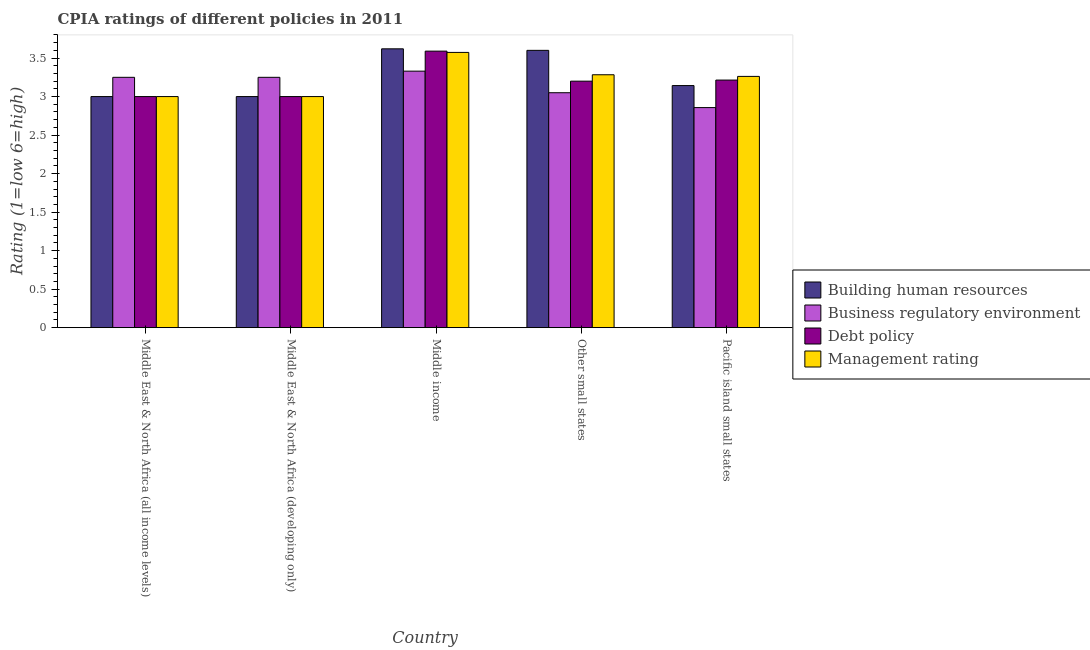How many different coloured bars are there?
Your response must be concise. 4. How many groups of bars are there?
Offer a terse response. 5. Are the number of bars per tick equal to the number of legend labels?
Offer a terse response. Yes. How many bars are there on the 2nd tick from the left?
Offer a terse response. 4. How many bars are there on the 1st tick from the right?
Ensure brevity in your answer.  4. What is the label of the 1st group of bars from the left?
Offer a very short reply. Middle East & North Africa (all income levels). In how many cases, is the number of bars for a given country not equal to the number of legend labels?
Provide a short and direct response. 0. Across all countries, what is the maximum cpia rating of business regulatory environment?
Offer a very short reply. 3.33. Across all countries, what is the minimum cpia rating of management?
Offer a very short reply. 3. In which country was the cpia rating of building human resources minimum?
Your answer should be very brief. Middle East & North Africa (all income levels). What is the total cpia rating of business regulatory environment in the graph?
Make the answer very short. 15.74. What is the difference between the cpia rating of debt policy in Other small states and that in Pacific island small states?
Your response must be concise. -0.01. What is the difference between the cpia rating of management in Pacific island small states and the cpia rating of business regulatory environment in Middle East & North Africa (developing only)?
Your answer should be very brief. 0.01. What is the average cpia rating of building human resources per country?
Keep it short and to the point. 3.27. What is the ratio of the cpia rating of management in Middle East & North Africa (all income levels) to that in Other small states?
Offer a very short reply. 0.91. Is the cpia rating of debt policy in Other small states less than that in Pacific island small states?
Keep it short and to the point. Yes. What is the difference between the highest and the second highest cpia rating of building human resources?
Your response must be concise. 0.02. What is the difference between the highest and the lowest cpia rating of building human resources?
Keep it short and to the point. 0.62. Is it the case that in every country, the sum of the cpia rating of business regulatory environment and cpia rating of debt policy is greater than the sum of cpia rating of management and cpia rating of building human resources?
Provide a succinct answer. Yes. What does the 2nd bar from the left in Middle East & North Africa (developing only) represents?
Provide a short and direct response. Business regulatory environment. What does the 4th bar from the right in Middle East & North Africa (all income levels) represents?
Ensure brevity in your answer.  Building human resources. Is it the case that in every country, the sum of the cpia rating of building human resources and cpia rating of business regulatory environment is greater than the cpia rating of debt policy?
Offer a very short reply. Yes. How many bars are there?
Your answer should be compact. 20. Are all the bars in the graph horizontal?
Offer a terse response. No. Are the values on the major ticks of Y-axis written in scientific E-notation?
Your answer should be compact. No. Does the graph contain grids?
Provide a succinct answer. No. Where does the legend appear in the graph?
Make the answer very short. Center right. What is the title of the graph?
Your response must be concise. CPIA ratings of different policies in 2011. Does "Norway" appear as one of the legend labels in the graph?
Offer a very short reply. No. What is the label or title of the X-axis?
Offer a very short reply. Country. What is the Rating (1=low 6=high) in Debt policy in Middle East & North Africa (all income levels)?
Make the answer very short. 3. What is the Rating (1=low 6=high) in Business regulatory environment in Middle East & North Africa (developing only)?
Your response must be concise. 3.25. What is the Rating (1=low 6=high) of Debt policy in Middle East & North Africa (developing only)?
Offer a very short reply. 3. What is the Rating (1=low 6=high) in Building human resources in Middle income?
Keep it short and to the point. 3.62. What is the Rating (1=low 6=high) of Business regulatory environment in Middle income?
Your answer should be very brief. 3.33. What is the Rating (1=low 6=high) of Debt policy in Middle income?
Your response must be concise. 3.59. What is the Rating (1=low 6=high) of Management rating in Middle income?
Make the answer very short. 3.57. What is the Rating (1=low 6=high) in Building human resources in Other small states?
Your answer should be compact. 3.6. What is the Rating (1=low 6=high) in Business regulatory environment in Other small states?
Offer a very short reply. 3.05. What is the Rating (1=low 6=high) of Management rating in Other small states?
Keep it short and to the point. 3.28. What is the Rating (1=low 6=high) in Building human resources in Pacific island small states?
Provide a succinct answer. 3.14. What is the Rating (1=low 6=high) of Business regulatory environment in Pacific island small states?
Provide a succinct answer. 2.86. What is the Rating (1=low 6=high) of Debt policy in Pacific island small states?
Offer a very short reply. 3.21. What is the Rating (1=low 6=high) of Management rating in Pacific island small states?
Offer a terse response. 3.26. Across all countries, what is the maximum Rating (1=low 6=high) of Building human resources?
Keep it short and to the point. 3.62. Across all countries, what is the maximum Rating (1=low 6=high) of Business regulatory environment?
Your answer should be very brief. 3.33. Across all countries, what is the maximum Rating (1=low 6=high) in Debt policy?
Ensure brevity in your answer.  3.59. Across all countries, what is the maximum Rating (1=low 6=high) of Management rating?
Make the answer very short. 3.57. Across all countries, what is the minimum Rating (1=low 6=high) of Building human resources?
Keep it short and to the point. 3. Across all countries, what is the minimum Rating (1=low 6=high) of Business regulatory environment?
Keep it short and to the point. 2.86. Across all countries, what is the minimum Rating (1=low 6=high) in Management rating?
Provide a succinct answer. 3. What is the total Rating (1=low 6=high) in Building human resources in the graph?
Offer a very short reply. 16.36. What is the total Rating (1=low 6=high) in Business regulatory environment in the graph?
Provide a succinct answer. 15.74. What is the total Rating (1=low 6=high) in Debt policy in the graph?
Give a very brief answer. 16. What is the total Rating (1=low 6=high) of Management rating in the graph?
Provide a short and direct response. 16.12. What is the difference between the Rating (1=low 6=high) in Building human resources in Middle East & North Africa (all income levels) and that in Middle income?
Offer a terse response. -0.62. What is the difference between the Rating (1=low 6=high) of Business regulatory environment in Middle East & North Africa (all income levels) and that in Middle income?
Give a very brief answer. -0.08. What is the difference between the Rating (1=low 6=high) in Debt policy in Middle East & North Africa (all income levels) and that in Middle income?
Your answer should be compact. -0.59. What is the difference between the Rating (1=low 6=high) of Management rating in Middle East & North Africa (all income levels) and that in Middle income?
Make the answer very short. -0.57. What is the difference between the Rating (1=low 6=high) of Business regulatory environment in Middle East & North Africa (all income levels) and that in Other small states?
Your response must be concise. 0.2. What is the difference between the Rating (1=low 6=high) in Debt policy in Middle East & North Africa (all income levels) and that in Other small states?
Offer a terse response. -0.2. What is the difference between the Rating (1=low 6=high) of Management rating in Middle East & North Africa (all income levels) and that in Other small states?
Ensure brevity in your answer.  -0.28. What is the difference between the Rating (1=low 6=high) of Building human resources in Middle East & North Africa (all income levels) and that in Pacific island small states?
Provide a succinct answer. -0.14. What is the difference between the Rating (1=low 6=high) of Business regulatory environment in Middle East & North Africa (all income levels) and that in Pacific island small states?
Give a very brief answer. 0.39. What is the difference between the Rating (1=low 6=high) of Debt policy in Middle East & North Africa (all income levels) and that in Pacific island small states?
Offer a terse response. -0.21. What is the difference between the Rating (1=low 6=high) in Management rating in Middle East & North Africa (all income levels) and that in Pacific island small states?
Ensure brevity in your answer.  -0.26. What is the difference between the Rating (1=low 6=high) in Building human resources in Middle East & North Africa (developing only) and that in Middle income?
Keep it short and to the point. -0.62. What is the difference between the Rating (1=low 6=high) of Business regulatory environment in Middle East & North Africa (developing only) and that in Middle income?
Keep it short and to the point. -0.08. What is the difference between the Rating (1=low 6=high) of Debt policy in Middle East & North Africa (developing only) and that in Middle income?
Provide a short and direct response. -0.59. What is the difference between the Rating (1=low 6=high) in Management rating in Middle East & North Africa (developing only) and that in Middle income?
Offer a terse response. -0.57. What is the difference between the Rating (1=low 6=high) in Building human resources in Middle East & North Africa (developing only) and that in Other small states?
Offer a very short reply. -0.6. What is the difference between the Rating (1=low 6=high) of Debt policy in Middle East & North Africa (developing only) and that in Other small states?
Offer a terse response. -0.2. What is the difference between the Rating (1=low 6=high) of Management rating in Middle East & North Africa (developing only) and that in Other small states?
Keep it short and to the point. -0.28. What is the difference between the Rating (1=low 6=high) in Building human resources in Middle East & North Africa (developing only) and that in Pacific island small states?
Make the answer very short. -0.14. What is the difference between the Rating (1=low 6=high) in Business regulatory environment in Middle East & North Africa (developing only) and that in Pacific island small states?
Keep it short and to the point. 0.39. What is the difference between the Rating (1=low 6=high) of Debt policy in Middle East & North Africa (developing only) and that in Pacific island small states?
Make the answer very short. -0.21. What is the difference between the Rating (1=low 6=high) of Management rating in Middle East & North Africa (developing only) and that in Pacific island small states?
Your response must be concise. -0.26. What is the difference between the Rating (1=low 6=high) in Business regulatory environment in Middle income and that in Other small states?
Offer a terse response. 0.28. What is the difference between the Rating (1=low 6=high) in Debt policy in Middle income and that in Other small states?
Give a very brief answer. 0.39. What is the difference between the Rating (1=low 6=high) of Management rating in Middle income and that in Other small states?
Keep it short and to the point. 0.29. What is the difference between the Rating (1=low 6=high) of Building human resources in Middle income and that in Pacific island small states?
Offer a terse response. 0.48. What is the difference between the Rating (1=low 6=high) of Business regulatory environment in Middle income and that in Pacific island small states?
Offer a very short reply. 0.47. What is the difference between the Rating (1=low 6=high) in Debt policy in Middle income and that in Pacific island small states?
Offer a very short reply. 0.38. What is the difference between the Rating (1=low 6=high) in Management rating in Middle income and that in Pacific island small states?
Your response must be concise. 0.31. What is the difference between the Rating (1=low 6=high) of Building human resources in Other small states and that in Pacific island small states?
Ensure brevity in your answer.  0.46. What is the difference between the Rating (1=low 6=high) in Business regulatory environment in Other small states and that in Pacific island small states?
Your answer should be very brief. 0.19. What is the difference between the Rating (1=low 6=high) in Debt policy in Other small states and that in Pacific island small states?
Ensure brevity in your answer.  -0.01. What is the difference between the Rating (1=low 6=high) in Management rating in Other small states and that in Pacific island small states?
Ensure brevity in your answer.  0.02. What is the difference between the Rating (1=low 6=high) in Building human resources in Middle East & North Africa (all income levels) and the Rating (1=low 6=high) in Business regulatory environment in Middle East & North Africa (developing only)?
Provide a short and direct response. -0.25. What is the difference between the Rating (1=low 6=high) of Business regulatory environment in Middle East & North Africa (all income levels) and the Rating (1=low 6=high) of Management rating in Middle East & North Africa (developing only)?
Your answer should be compact. 0.25. What is the difference between the Rating (1=low 6=high) of Building human resources in Middle East & North Africa (all income levels) and the Rating (1=low 6=high) of Business regulatory environment in Middle income?
Your answer should be very brief. -0.33. What is the difference between the Rating (1=low 6=high) of Building human resources in Middle East & North Africa (all income levels) and the Rating (1=low 6=high) of Debt policy in Middle income?
Offer a very short reply. -0.59. What is the difference between the Rating (1=low 6=high) in Building human resources in Middle East & North Africa (all income levels) and the Rating (1=low 6=high) in Management rating in Middle income?
Offer a very short reply. -0.57. What is the difference between the Rating (1=low 6=high) of Business regulatory environment in Middle East & North Africa (all income levels) and the Rating (1=low 6=high) of Debt policy in Middle income?
Make the answer very short. -0.34. What is the difference between the Rating (1=low 6=high) in Business regulatory environment in Middle East & North Africa (all income levels) and the Rating (1=low 6=high) in Management rating in Middle income?
Provide a succinct answer. -0.32. What is the difference between the Rating (1=low 6=high) of Debt policy in Middle East & North Africa (all income levels) and the Rating (1=low 6=high) of Management rating in Middle income?
Give a very brief answer. -0.57. What is the difference between the Rating (1=low 6=high) in Building human resources in Middle East & North Africa (all income levels) and the Rating (1=low 6=high) in Debt policy in Other small states?
Ensure brevity in your answer.  -0.2. What is the difference between the Rating (1=low 6=high) in Building human resources in Middle East & North Africa (all income levels) and the Rating (1=low 6=high) in Management rating in Other small states?
Your response must be concise. -0.28. What is the difference between the Rating (1=low 6=high) of Business regulatory environment in Middle East & North Africa (all income levels) and the Rating (1=low 6=high) of Debt policy in Other small states?
Your response must be concise. 0.05. What is the difference between the Rating (1=low 6=high) in Business regulatory environment in Middle East & North Africa (all income levels) and the Rating (1=low 6=high) in Management rating in Other small states?
Give a very brief answer. -0.03. What is the difference between the Rating (1=low 6=high) of Debt policy in Middle East & North Africa (all income levels) and the Rating (1=low 6=high) of Management rating in Other small states?
Your answer should be compact. -0.28. What is the difference between the Rating (1=low 6=high) in Building human resources in Middle East & North Africa (all income levels) and the Rating (1=low 6=high) in Business regulatory environment in Pacific island small states?
Your answer should be very brief. 0.14. What is the difference between the Rating (1=low 6=high) in Building human resources in Middle East & North Africa (all income levels) and the Rating (1=low 6=high) in Debt policy in Pacific island small states?
Ensure brevity in your answer.  -0.21. What is the difference between the Rating (1=low 6=high) in Building human resources in Middle East & North Africa (all income levels) and the Rating (1=low 6=high) in Management rating in Pacific island small states?
Your answer should be very brief. -0.26. What is the difference between the Rating (1=low 6=high) in Business regulatory environment in Middle East & North Africa (all income levels) and the Rating (1=low 6=high) in Debt policy in Pacific island small states?
Ensure brevity in your answer.  0.04. What is the difference between the Rating (1=low 6=high) in Business regulatory environment in Middle East & North Africa (all income levels) and the Rating (1=low 6=high) in Management rating in Pacific island small states?
Your response must be concise. -0.01. What is the difference between the Rating (1=low 6=high) in Debt policy in Middle East & North Africa (all income levels) and the Rating (1=low 6=high) in Management rating in Pacific island small states?
Make the answer very short. -0.26. What is the difference between the Rating (1=low 6=high) in Building human resources in Middle East & North Africa (developing only) and the Rating (1=low 6=high) in Business regulatory environment in Middle income?
Provide a short and direct response. -0.33. What is the difference between the Rating (1=low 6=high) in Building human resources in Middle East & North Africa (developing only) and the Rating (1=low 6=high) in Debt policy in Middle income?
Keep it short and to the point. -0.59. What is the difference between the Rating (1=low 6=high) in Building human resources in Middle East & North Africa (developing only) and the Rating (1=low 6=high) in Management rating in Middle income?
Your answer should be compact. -0.57. What is the difference between the Rating (1=low 6=high) of Business regulatory environment in Middle East & North Africa (developing only) and the Rating (1=low 6=high) of Debt policy in Middle income?
Ensure brevity in your answer.  -0.34. What is the difference between the Rating (1=low 6=high) of Business regulatory environment in Middle East & North Africa (developing only) and the Rating (1=low 6=high) of Management rating in Middle income?
Ensure brevity in your answer.  -0.32. What is the difference between the Rating (1=low 6=high) of Debt policy in Middle East & North Africa (developing only) and the Rating (1=low 6=high) of Management rating in Middle income?
Ensure brevity in your answer.  -0.57. What is the difference between the Rating (1=low 6=high) of Building human resources in Middle East & North Africa (developing only) and the Rating (1=low 6=high) of Debt policy in Other small states?
Your answer should be compact. -0.2. What is the difference between the Rating (1=low 6=high) in Building human resources in Middle East & North Africa (developing only) and the Rating (1=low 6=high) in Management rating in Other small states?
Give a very brief answer. -0.28. What is the difference between the Rating (1=low 6=high) of Business regulatory environment in Middle East & North Africa (developing only) and the Rating (1=low 6=high) of Debt policy in Other small states?
Ensure brevity in your answer.  0.05. What is the difference between the Rating (1=low 6=high) in Business regulatory environment in Middle East & North Africa (developing only) and the Rating (1=low 6=high) in Management rating in Other small states?
Give a very brief answer. -0.03. What is the difference between the Rating (1=low 6=high) of Debt policy in Middle East & North Africa (developing only) and the Rating (1=low 6=high) of Management rating in Other small states?
Offer a terse response. -0.28. What is the difference between the Rating (1=low 6=high) in Building human resources in Middle East & North Africa (developing only) and the Rating (1=low 6=high) in Business regulatory environment in Pacific island small states?
Give a very brief answer. 0.14. What is the difference between the Rating (1=low 6=high) in Building human resources in Middle East & North Africa (developing only) and the Rating (1=low 6=high) in Debt policy in Pacific island small states?
Your response must be concise. -0.21. What is the difference between the Rating (1=low 6=high) in Building human resources in Middle East & North Africa (developing only) and the Rating (1=low 6=high) in Management rating in Pacific island small states?
Offer a terse response. -0.26. What is the difference between the Rating (1=low 6=high) in Business regulatory environment in Middle East & North Africa (developing only) and the Rating (1=low 6=high) in Debt policy in Pacific island small states?
Keep it short and to the point. 0.04. What is the difference between the Rating (1=low 6=high) of Business regulatory environment in Middle East & North Africa (developing only) and the Rating (1=low 6=high) of Management rating in Pacific island small states?
Provide a succinct answer. -0.01. What is the difference between the Rating (1=low 6=high) in Debt policy in Middle East & North Africa (developing only) and the Rating (1=low 6=high) in Management rating in Pacific island small states?
Offer a terse response. -0.26. What is the difference between the Rating (1=low 6=high) of Building human resources in Middle income and the Rating (1=low 6=high) of Business regulatory environment in Other small states?
Offer a terse response. 0.57. What is the difference between the Rating (1=low 6=high) of Building human resources in Middle income and the Rating (1=low 6=high) of Debt policy in Other small states?
Keep it short and to the point. 0.42. What is the difference between the Rating (1=low 6=high) in Building human resources in Middle income and the Rating (1=low 6=high) in Management rating in Other small states?
Keep it short and to the point. 0.34. What is the difference between the Rating (1=low 6=high) in Business regulatory environment in Middle income and the Rating (1=low 6=high) in Debt policy in Other small states?
Offer a very short reply. 0.13. What is the difference between the Rating (1=low 6=high) of Business regulatory environment in Middle income and the Rating (1=low 6=high) of Management rating in Other small states?
Your answer should be very brief. 0.05. What is the difference between the Rating (1=low 6=high) of Debt policy in Middle income and the Rating (1=low 6=high) of Management rating in Other small states?
Give a very brief answer. 0.31. What is the difference between the Rating (1=low 6=high) in Building human resources in Middle income and the Rating (1=low 6=high) in Business regulatory environment in Pacific island small states?
Offer a very short reply. 0.76. What is the difference between the Rating (1=low 6=high) in Building human resources in Middle income and the Rating (1=low 6=high) in Debt policy in Pacific island small states?
Give a very brief answer. 0.41. What is the difference between the Rating (1=low 6=high) of Building human resources in Middle income and the Rating (1=low 6=high) of Management rating in Pacific island small states?
Offer a terse response. 0.36. What is the difference between the Rating (1=low 6=high) in Business regulatory environment in Middle income and the Rating (1=low 6=high) in Debt policy in Pacific island small states?
Offer a terse response. 0.12. What is the difference between the Rating (1=low 6=high) in Business regulatory environment in Middle income and the Rating (1=low 6=high) in Management rating in Pacific island small states?
Keep it short and to the point. 0.07. What is the difference between the Rating (1=low 6=high) of Debt policy in Middle income and the Rating (1=low 6=high) of Management rating in Pacific island small states?
Give a very brief answer. 0.33. What is the difference between the Rating (1=low 6=high) of Building human resources in Other small states and the Rating (1=low 6=high) of Business regulatory environment in Pacific island small states?
Offer a terse response. 0.74. What is the difference between the Rating (1=low 6=high) in Building human resources in Other small states and the Rating (1=low 6=high) in Debt policy in Pacific island small states?
Keep it short and to the point. 0.39. What is the difference between the Rating (1=low 6=high) in Building human resources in Other small states and the Rating (1=low 6=high) in Management rating in Pacific island small states?
Offer a terse response. 0.34. What is the difference between the Rating (1=low 6=high) in Business regulatory environment in Other small states and the Rating (1=low 6=high) in Debt policy in Pacific island small states?
Provide a short and direct response. -0.16. What is the difference between the Rating (1=low 6=high) in Business regulatory environment in Other small states and the Rating (1=low 6=high) in Management rating in Pacific island small states?
Offer a very short reply. -0.21. What is the difference between the Rating (1=low 6=high) of Debt policy in Other small states and the Rating (1=low 6=high) of Management rating in Pacific island small states?
Provide a succinct answer. -0.06. What is the average Rating (1=low 6=high) of Building human resources per country?
Provide a short and direct response. 3.27. What is the average Rating (1=low 6=high) of Business regulatory environment per country?
Give a very brief answer. 3.15. What is the average Rating (1=low 6=high) in Debt policy per country?
Your response must be concise. 3.2. What is the average Rating (1=low 6=high) in Management rating per country?
Ensure brevity in your answer.  3.22. What is the difference between the Rating (1=low 6=high) in Building human resources and Rating (1=low 6=high) in Business regulatory environment in Middle East & North Africa (all income levels)?
Provide a succinct answer. -0.25. What is the difference between the Rating (1=low 6=high) in Building human resources and Rating (1=low 6=high) in Management rating in Middle East & North Africa (all income levels)?
Offer a very short reply. 0. What is the difference between the Rating (1=low 6=high) in Business regulatory environment and Rating (1=low 6=high) in Management rating in Middle East & North Africa (all income levels)?
Your answer should be compact. 0.25. What is the difference between the Rating (1=low 6=high) in Debt policy and Rating (1=low 6=high) in Management rating in Middle East & North Africa (all income levels)?
Offer a very short reply. 0. What is the difference between the Rating (1=low 6=high) of Building human resources and Rating (1=low 6=high) of Business regulatory environment in Middle East & North Africa (developing only)?
Offer a very short reply. -0.25. What is the difference between the Rating (1=low 6=high) in Business regulatory environment and Rating (1=low 6=high) in Debt policy in Middle East & North Africa (developing only)?
Make the answer very short. 0.25. What is the difference between the Rating (1=low 6=high) of Business regulatory environment and Rating (1=low 6=high) of Management rating in Middle East & North Africa (developing only)?
Make the answer very short. 0.25. What is the difference between the Rating (1=low 6=high) in Debt policy and Rating (1=low 6=high) in Management rating in Middle East & North Africa (developing only)?
Keep it short and to the point. 0. What is the difference between the Rating (1=low 6=high) of Building human resources and Rating (1=low 6=high) of Business regulatory environment in Middle income?
Your response must be concise. 0.29. What is the difference between the Rating (1=low 6=high) of Building human resources and Rating (1=low 6=high) of Debt policy in Middle income?
Provide a succinct answer. 0.03. What is the difference between the Rating (1=low 6=high) in Building human resources and Rating (1=low 6=high) in Management rating in Middle income?
Ensure brevity in your answer.  0.05. What is the difference between the Rating (1=low 6=high) in Business regulatory environment and Rating (1=low 6=high) in Debt policy in Middle income?
Your response must be concise. -0.26. What is the difference between the Rating (1=low 6=high) in Business regulatory environment and Rating (1=low 6=high) in Management rating in Middle income?
Make the answer very short. -0.24. What is the difference between the Rating (1=low 6=high) in Debt policy and Rating (1=low 6=high) in Management rating in Middle income?
Your answer should be compact. 0.02. What is the difference between the Rating (1=low 6=high) of Building human resources and Rating (1=low 6=high) of Business regulatory environment in Other small states?
Provide a succinct answer. 0.55. What is the difference between the Rating (1=low 6=high) in Building human resources and Rating (1=low 6=high) in Debt policy in Other small states?
Keep it short and to the point. 0.4. What is the difference between the Rating (1=low 6=high) of Building human resources and Rating (1=low 6=high) of Management rating in Other small states?
Ensure brevity in your answer.  0.32. What is the difference between the Rating (1=low 6=high) of Business regulatory environment and Rating (1=low 6=high) of Management rating in Other small states?
Offer a very short reply. -0.23. What is the difference between the Rating (1=low 6=high) in Debt policy and Rating (1=low 6=high) in Management rating in Other small states?
Give a very brief answer. -0.08. What is the difference between the Rating (1=low 6=high) in Building human resources and Rating (1=low 6=high) in Business regulatory environment in Pacific island small states?
Your response must be concise. 0.29. What is the difference between the Rating (1=low 6=high) in Building human resources and Rating (1=low 6=high) in Debt policy in Pacific island small states?
Offer a terse response. -0.07. What is the difference between the Rating (1=low 6=high) in Building human resources and Rating (1=low 6=high) in Management rating in Pacific island small states?
Offer a very short reply. -0.12. What is the difference between the Rating (1=low 6=high) in Business regulatory environment and Rating (1=low 6=high) in Debt policy in Pacific island small states?
Your response must be concise. -0.36. What is the difference between the Rating (1=low 6=high) in Business regulatory environment and Rating (1=low 6=high) in Management rating in Pacific island small states?
Provide a succinct answer. -0.4. What is the difference between the Rating (1=low 6=high) in Debt policy and Rating (1=low 6=high) in Management rating in Pacific island small states?
Keep it short and to the point. -0.05. What is the ratio of the Rating (1=low 6=high) of Building human resources in Middle East & North Africa (all income levels) to that in Middle East & North Africa (developing only)?
Provide a short and direct response. 1. What is the ratio of the Rating (1=low 6=high) of Business regulatory environment in Middle East & North Africa (all income levels) to that in Middle East & North Africa (developing only)?
Make the answer very short. 1. What is the ratio of the Rating (1=low 6=high) in Debt policy in Middle East & North Africa (all income levels) to that in Middle East & North Africa (developing only)?
Provide a short and direct response. 1. What is the ratio of the Rating (1=low 6=high) in Building human resources in Middle East & North Africa (all income levels) to that in Middle income?
Your response must be concise. 0.83. What is the ratio of the Rating (1=low 6=high) of Business regulatory environment in Middle East & North Africa (all income levels) to that in Middle income?
Offer a terse response. 0.98. What is the ratio of the Rating (1=low 6=high) in Debt policy in Middle East & North Africa (all income levels) to that in Middle income?
Your answer should be very brief. 0.84. What is the ratio of the Rating (1=low 6=high) of Management rating in Middle East & North Africa (all income levels) to that in Middle income?
Provide a short and direct response. 0.84. What is the ratio of the Rating (1=low 6=high) of Business regulatory environment in Middle East & North Africa (all income levels) to that in Other small states?
Ensure brevity in your answer.  1.07. What is the ratio of the Rating (1=low 6=high) in Debt policy in Middle East & North Africa (all income levels) to that in Other small states?
Provide a short and direct response. 0.94. What is the ratio of the Rating (1=low 6=high) in Management rating in Middle East & North Africa (all income levels) to that in Other small states?
Give a very brief answer. 0.91. What is the ratio of the Rating (1=low 6=high) in Building human resources in Middle East & North Africa (all income levels) to that in Pacific island small states?
Provide a succinct answer. 0.95. What is the ratio of the Rating (1=low 6=high) of Business regulatory environment in Middle East & North Africa (all income levels) to that in Pacific island small states?
Make the answer very short. 1.14. What is the ratio of the Rating (1=low 6=high) in Debt policy in Middle East & North Africa (all income levels) to that in Pacific island small states?
Keep it short and to the point. 0.93. What is the ratio of the Rating (1=low 6=high) in Management rating in Middle East & North Africa (all income levels) to that in Pacific island small states?
Your answer should be very brief. 0.92. What is the ratio of the Rating (1=low 6=high) of Building human resources in Middle East & North Africa (developing only) to that in Middle income?
Provide a short and direct response. 0.83. What is the ratio of the Rating (1=low 6=high) of Debt policy in Middle East & North Africa (developing only) to that in Middle income?
Offer a very short reply. 0.84. What is the ratio of the Rating (1=low 6=high) in Management rating in Middle East & North Africa (developing only) to that in Middle income?
Your answer should be very brief. 0.84. What is the ratio of the Rating (1=low 6=high) of Business regulatory environment in Middle East & North Africa (developing only) to that in Other small states?
Give a very brief answer. 1.07. What is the ratio of the Rating (1=low 6=high) in Management rating in Middle East & North Africa (developing only) to that in Other small states?
Provide a succinct answer. 0.91. What is the ratio of the Rating (1=low 6=high) in Building human resources in Middle East & North Africa (developing only) to that in Pacific island small states?
Offer a terse response. 0.95. What is the ratio of the Rating (1=low 6=high) of Business regulatory environment in Middle East & North Africa (developing only) to that in Pacific island small states?
Your answer should be very brief. 1.14. What is the ratio of the Rating (1=low 6=high) in Management rating in Middle East & North Africa (developing only) to that in Pacific island small states?
Make the answer very short. 0.92. What is the ratio of the Rating (1=low 6=high) of Building human resources in Middle income to that in Other small states?
Ensure brevity in your answer.  1.01. What is the ratio of the Rating (1=low 6=high) in Business regulatory environment in Middle income to that in Other small states?
Your answer should be compact. 1.09. What is the ratio of the Rating (1=low 6=high) in Debt policy in Middle income to that in Other small states?
Ensure brevity in your answer.  1.12. What is the ratio of the Rating (1=low 6=high) of Management rating in Middle income to that in Other small states?
Ensure brevity in your answer.  1.09. What is the ratio of the Rating (1=low 6=high) of Building human resources in Middle income to that in Pacific island small states?
Your answer should be compact. 1.15. What is the ratio of the Rating (1=low 6=high) in Business regulatory environment in Middle income to that in Pacific island small states?
Provide a succinct answer. 1.17. What is the ratio of the Rating (1=low 6=high) of Debt policy in Middle income to that in Pacific island small states?
Provide a short and direct response. 1.12. What is the ratio of the Rating (1=low 6=high) in Management rating in Middle income to that in Pacific island small states?
Provide a succinct answer. 1.1. What is the ratio of the Rating (1=low 6=high) of Building human resources in Other small states to that in Pacific island small states?
Offer a very short reply. 1.15. What is the ratio of the Rating (1=low 6=high) of Business regulatory environment in Other small states to that in Pacific island small states?
Keep it short and to the point. 1.07. What is the ratio of the Rating (1=low 6=high) of Debt policy in Other small states to that in Pacific island small states?
Your answer should be compact. 1. What is the ratio of the Rating (1=low 6=high) of Management rating in Other small states to that in Pacific island small states?
Your answer should be very brief. 1.01. What is the difference between the highest and the second highest Rating (1=low 6=high) of Building human resources?
Your answer should be very brief. 0.02. What is the difference between the highest and the second highest Rating (1=low 6=high) of Debt policy?
Provide a short and direct response. 0.38. What is the difference between the highest and the second highest Rating (1=low 6=high) in Management rating?
Ensure brevity in your answer.  0.29. What is the difference between the highest and the lowest Rating (1=low 6=high) of Building human resources?
Make the answer very short. 0.62. What is the difference between the highest and the lowest Rating (1=low 6=high) in Business regulatory environment?
Offer a terse response. 0.47. What is the difference between the highest and the lowest Rating (1=low 6=high) of Debt policy?
Your answer should be very brief. 0.59. What is the difference between the highest and the lowest Rating (1=low 6=high) in Management rating?
Make the answer very short. 0.57. 